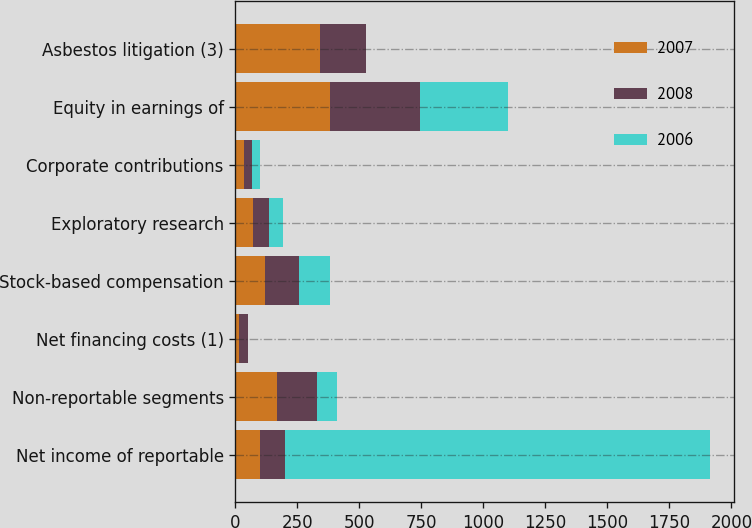Convert chart to OTSL. <chart><loc_0><loc_0><loc_500><loc_500><stacked_bar_chart><ecel><fcel>Net income of reportable<fcel>Non-reportable segments<fcel>Net financing costs (1)<fcel>Stock-based compensation<fcel>Exploratory research<fcel>Corporate contributions<fcel>Equity in earnings of<fcel>Asbestos litigation (3)<nl><fcel>2007<fcel>100<fcel>168<fcel>15<fcel>118<fcel>69<fcel>35<fcel>382<fcel>340<nl><fcel>2008<fcel>100<fcel>161<fcel>36<fcel>138<fcel>67<fcel>32<fcel>363<fcel>185<nl><fcel>2006<fcel>1713<fcel>82<fcel>1<fcel>127<fcel>57<fcel>30<fcel>352<fcel>2<nl></chart> 